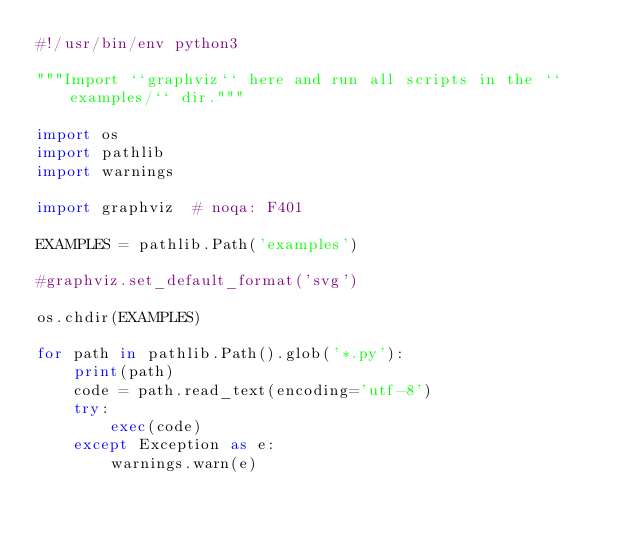<code> <loc_0><loc_0><loc_500><loc_500><_Python_>#!/usr/bin/env python3

"""Import ``graphviz`` here and run all scripts in the ``examples/`` dir."""

import os
import pathlib
import warnings

import graphviz  # noqa: F401

EXAMPLES = pathlib.Path('examples')

#graphviz.set_default_format('svg')

os.chdir(EXAMPLES)

for path in pathlib.Path().glob('*.py'):
    print(path)
    code = path.read_text(encoding='utf-8')
    try:
        exec(code)
    except Exception as e:
        warnings.warn(e)
</code> 